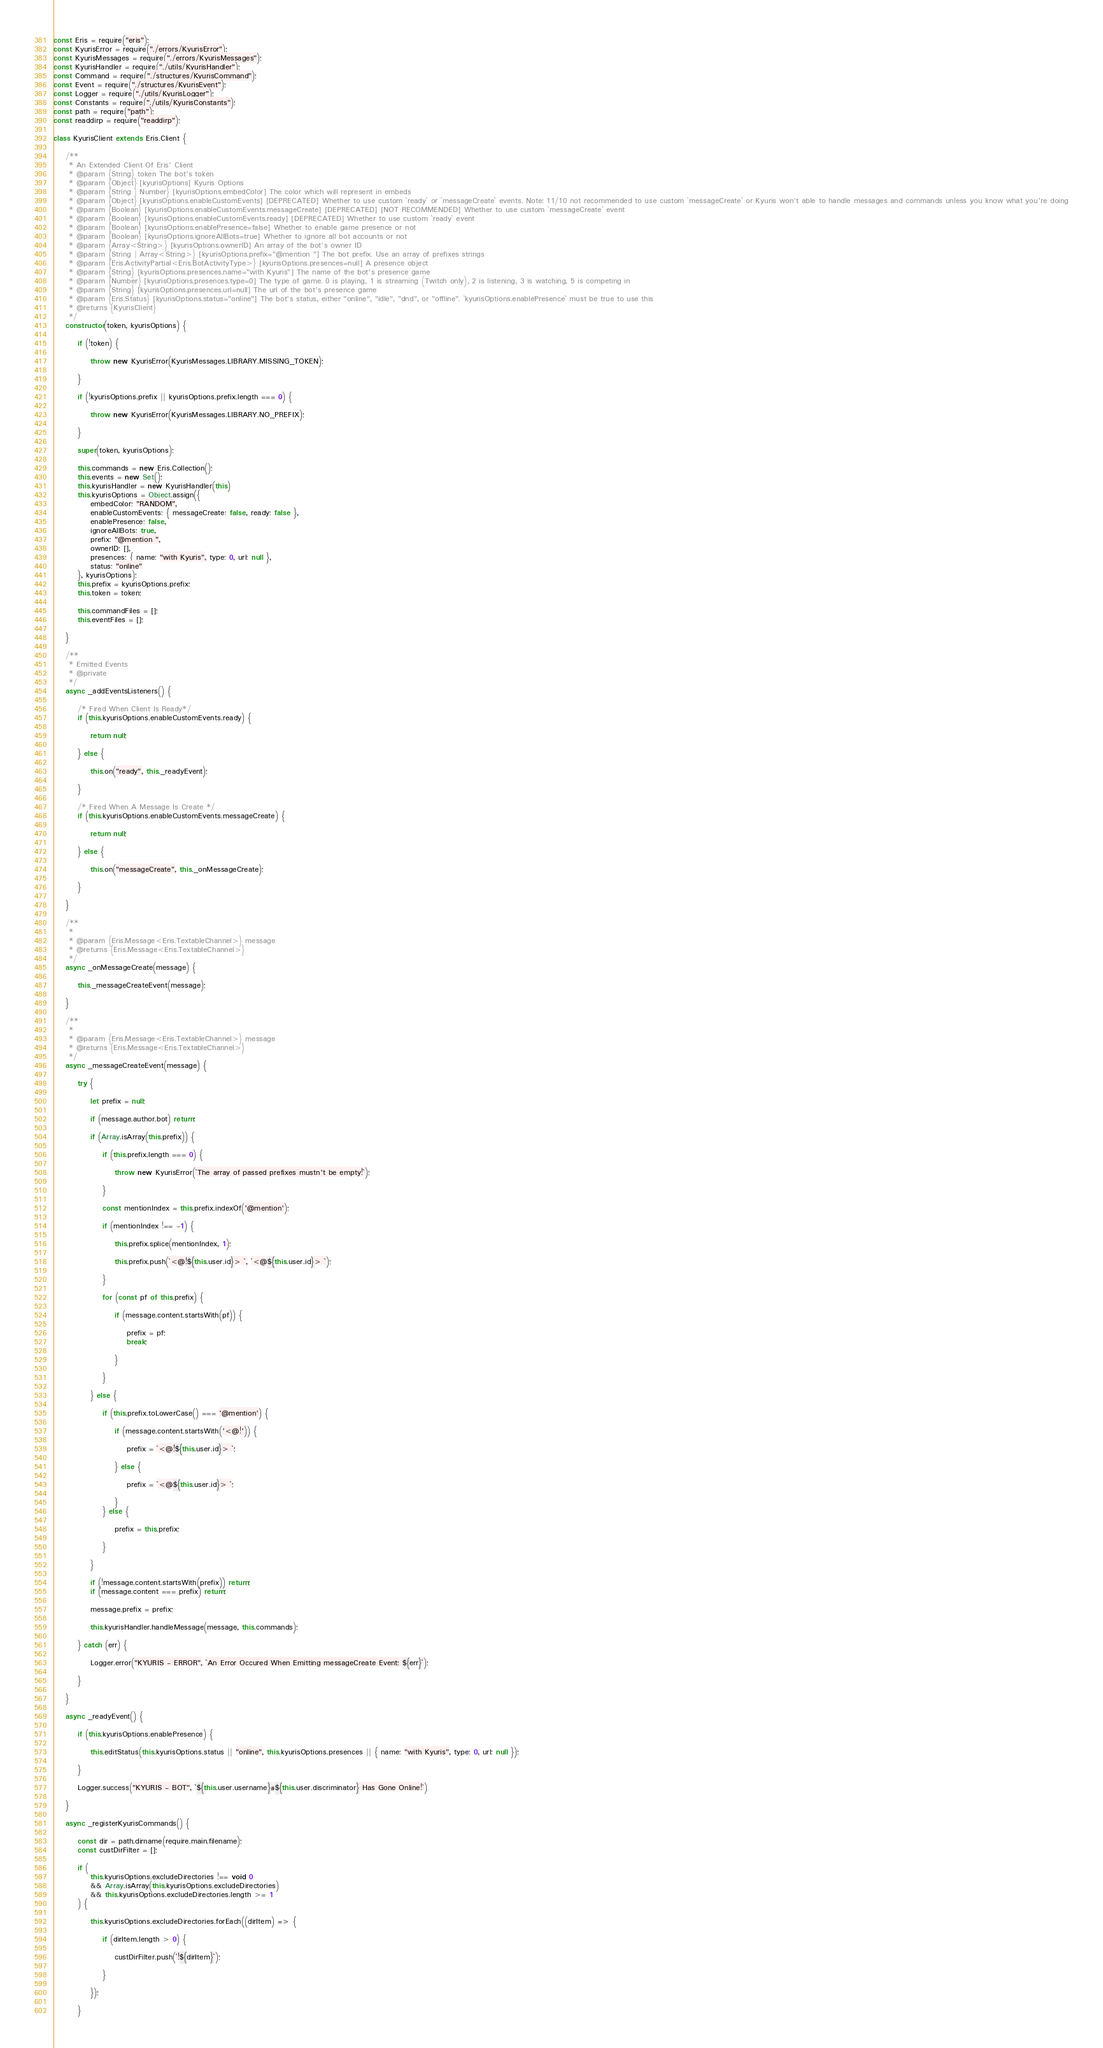Convert code to text. <code><loc_0><loc_0><loc_500><loc_500><_JavaScript_>const Eris = require("eris");
const KyurisError = require("./errors/KyurisError");
const KyurisMessages = require("./errors/KyurisMessages");
const KyurisHandler = require("./utils/KyurisHandler");
const Command = require("./structures/KyurisCommand");
const Event = require("./structures/KyurisEvent");
const Logger = require("./utils/KyurisLogger");
const Constants = require("./utils/KyurisConstants");
const path = require("path");
const readdirp = require("readdirp");

class KyurisClient extends Eris.Client {

    /**
     * An Extended Client Of Eris' Client
     * @param {String} token The bot's token
     * @param {Object} [kyurisOptions] Kyuris Options
     * @param {String | Number} [kyurisOptions.embedColor] The color which will represent in embeds
     * @param {Object} [kyurisOptions.enableCustomEvents] [DEPRECATED] Whether to use custom `ready` or `messageCreate` events. Note: 11/10 not recommended to use custom `messageCreate` or Kyuris won't able to handle messages and commands unless you know what you're doing
     * @param {Boolean} [kyurisOptions.enableCustomEvents.messageCreate] [DEPRECATED] [NOT RECOMMENDED] Whether to use custom `messageCreate` event
     * @param {Boolean} [kyurisOptions.enableCustomEvents.ready] [DEPRECATED] Whether to use custom `ready` event
     * @param {Boolean} [kyurisOptions.enablePresence=false] Whether to enable game presence or not
     * @param {Boolean} [kyurisOptions.ignoreAllBots=true] Whether to ignore all bot accounts or not
     * @param {Array<String>} [kyurisOptions.ownerID] An array of the bot's owner ID
     * @param {String | Array<String>} [kyurisOptions.prefix="@mention "] The bot prefix. Use an array of prefixes strings
     * @param {Eris.ActivityPartial<Eris.BotActivityType>} [kyurisOptions.presences=null] A presence object
     * @param {String} [kyurisOptions.presences.name="with Kyuris"] The name of the bot's presence game
     * @param {Number} [kyurisOptions.presences.type=0] The type of game. 0 is playing, 1 is streaming (Twitch only), 2 is listening, 3 is watching, 5 is competing in
     * @param {String} [kyurisOptions.presences.url=null] The url of the bot's presence game
     * @param {Eris.Status} [kyurisOptions.status="online"] The bot's status, either "online", "idle", "dnd", or "offline". `kyurisOptions.enablePresence` must be true to use this
     * @returns {KyurisClient}
     */
    constructor(token, kyurisOptions) {

        if (!token) {

            throw new KyurisError(KyurisMessages.LIBRARY.MISSING_TOKEN);

        }

        if (!kyurisOptions.prefix || kyurisOptions.prefix.length === 0) {

            throw new KyurisError(KyurisMessages.LIBRARY.NO_PREFIX);

        }

        super(token, kyurisOptions);

        this.commands = new Eris.Collection();
        this.events = new Set();
        this.kyurisHandler = new KyurisHandler(this)
        this.kyurisOptions = Object.assign({
            embedColor: "RANDOM",
            enableCustomEvents: { messageCreate: false, ready: false },
            enablePresence: false,
            ignoreAllBots: true,
            prefix: "@mention ",
            ownerID: [],
            presences: { name: "with Kyuris", type: 0, url: null },
            status: "online"
        }, kyurisOptions);
        this.prefix = kyurisOptions.prefix;
        this.token = token;

        this.commandFiles = [];
        this.eventFiles = [];

    }

    /**
     * Emitted Events
     * @private
     */
    async _addEventsListeners() {

        /* Fired When Client Is Ready*/
        if (this.kyurisOptions.enableCustomEvents.ready) {

            return null;

        } else {

            this.on("ready", this._readyEvent);

        }

        /* Fired When A Message Is Create */
        if (this.kyurisOptions.enableCustomEvents.messageCreate) {

            return null;

        } else {

            this.on("messageCreate", this._onMessageCreate);

        }

    }

    /**
     * 
     * @param {Eris.Message<Eris.TextableChannel>} message 
     * @returns {Eris.Message<Eris.TextableChannel>}
     */
    async _onMessageCreate(message) {

        this._messageCreateEvent(message);

    }

    /**
     * 
     * @param {Eris.Message<Eris.TextableChannel>} message 
     * @returns {Eris.Message<Eris.TextableChannel>}
     */
    async _messageCreateEvent(message) {

        try {

            let prefix = null;

            if (message.author.bot) return;

            if (Array.isArray(this.prefix)) {

                if (this.prefix.length === 0) {

                    throw new KyurisError(`The array of passed prefixes mustn't be empty!`);
              
                }

                const mentionIndex = this.prefix.indexOf('@mention');

                if (mentionIndex !== -1) {

                    this.prefix.splice(mentionIndex, 1);

                    this.prefix.push(`<@!${this.user.id}> `, `<@${this.user.id}> `);
              
                }
                
                for (const pf of this.prefix) {

                    if (message.content.startsWith(pf)) {

                        prefix = pf;
                        break;
                 
                    }
               
                }

            } else {
               
                if (this.prefix.toLowerCase() === '@mention') {

                    if (message.content.startsWith('<@!')) {

                        prefix = `<@!${this.user.id}> `;
                
                    } else {

                        prefix = `<@${this.user.id}> `;
                 
                    }
                } else {

                    prefix = this.prefix;
               
                }

            }

            if (!message.content.startsWith(prefix)) return;
            if (message.content === prefix) return;

            message.prefix = prefix;

            this.kyurisHandler.handleMessage(message, this.commands);

        } catch (err) {
            
            Logger.error("KYURIS - ERROR", `An Error Occured When Emitting messageCreate Event: ${err}`);

        }

    }

    async _readyEvent() {

        if (this.kyurisOptions.enablePresence) {

            this.editStatus(this.kyurisOptions.status || "online", this.kyurisOptions.presences || { name: "with Kyuris", type: 0, url: null });

        }

        Logger.success("KYURIS - BOT", `${this.user.username}#${this.user.discriminator} Has Gone Online!`)

    }

    async _registerKyurisCommands() {

        const dir = path.dirname(require.main.filename);
        const custDirFilter = [];

        if (
            this.kyurisOptions.excludeDirectories !== void 0
            && Array.isArray(this.kyurisOptions.excludeDirectories)
            && this.kyurisOptions.excludeDirectories.length >= 1
        ) {

            this.kyurisOptions.excludeDirectories.forEach((dirItem) => {

                if (dirItem.length > 0) {

                    custDirFilter.push(`!${dirItem}`);

                }

            });

        }
</code> 